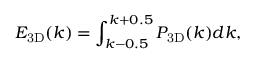<formula> <loc_0><loc_0><loc_500><loc_500>E _ { 3 D } ( k ) = \int _ { k - 0 . 5 } ^ { k + 0 . 5 } P _ { 3 D } ( k ) d k ,</formula> 